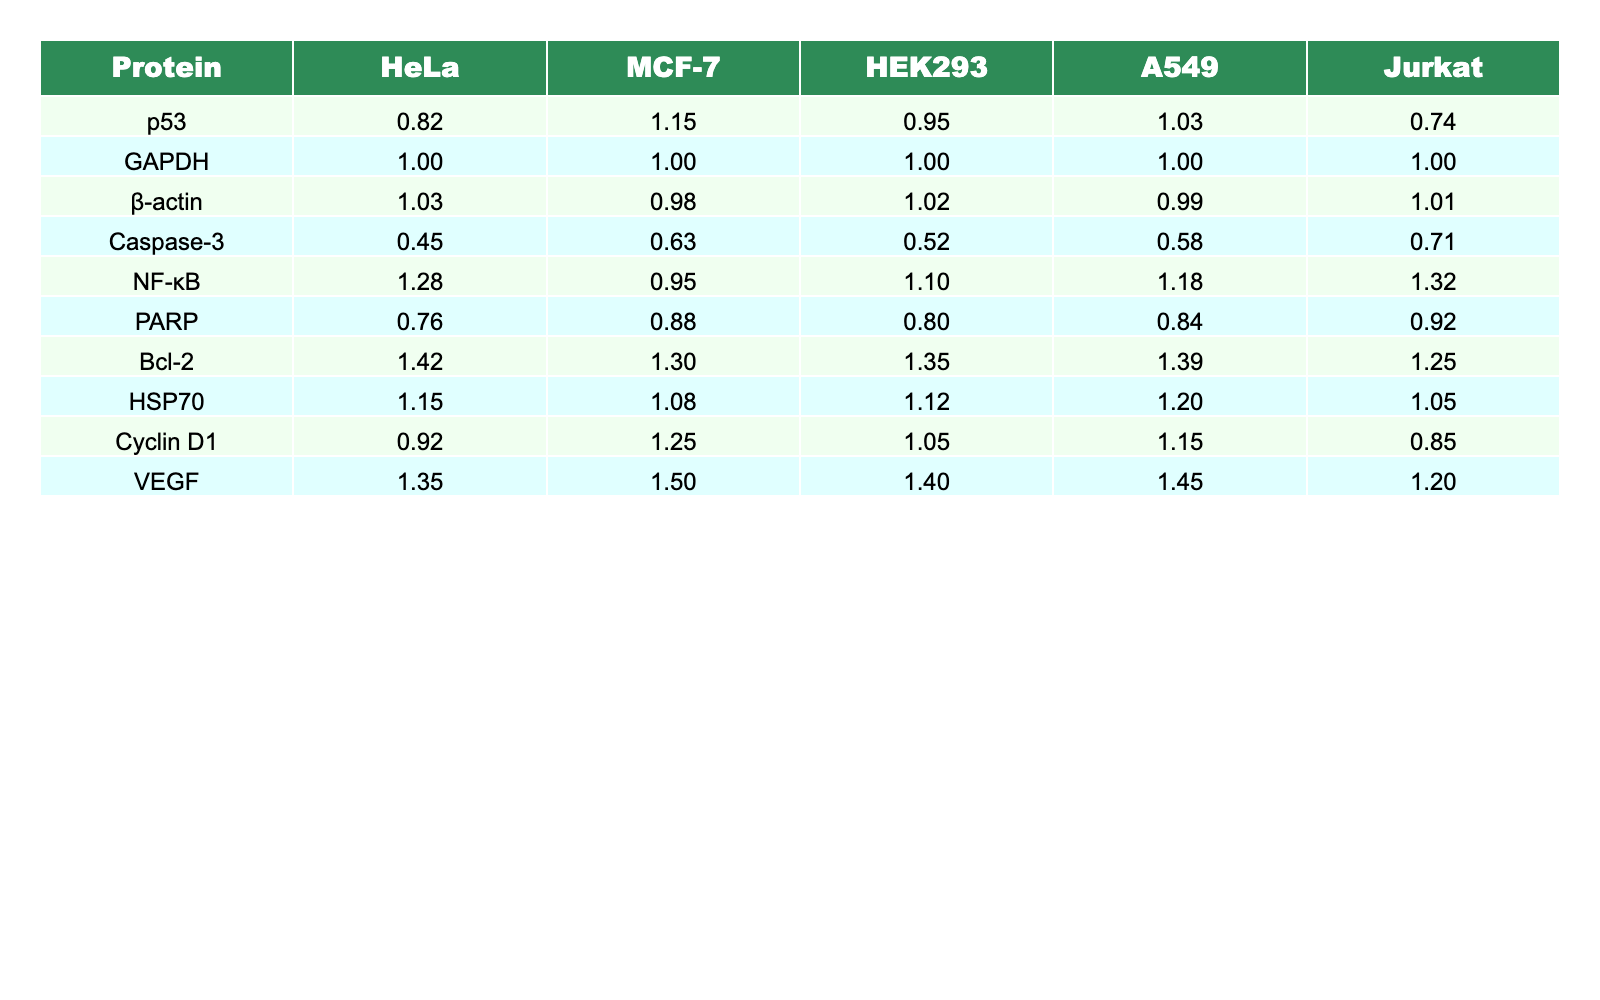What is the value of p53 in MCF-7? The value for p53 in the MCF-7 cell line is clearly indicated in the table under the MCF-7 column, which is 1.15.
Answer: 1.15 Which protein has the highest value in HEK293? By examining the HEK293 column, the protein with the highest quantification value is Bcl-2, which has a value of 1.35.
Answer: Bcl-2 What is the average expression level of Caspase-3 across all cell lines? To find the average expression level of Caspase-3, we need to sum the values (0.45 + 0.63 + 0.52 + 0.58 + 0.71) which equals 2.89, and then divide by the number of cell lines (5). The average is 2.89 / 5 = 0.578.
Answer: 0.578 Is the expression level of VEGF higher in Jurkat than in HeLa? Comparing the values in the table, Jurkat has a value of 1.20 for VEGF, while HeLa has a value of 1.35. Since 1.20 is less than 1.35, the statement is false.
Answer: No What is the difference in expression levels of NF-κB between HeLa and A549? The value for NF-κB in HeLa is 1.28 and in A549 is 1.18. The difference is calculated as 1.28 - 1.18 = 0.10.
Answer: 0.10 Which proteins have expression levels above 1.2 in Jurkat? Looking through the Jurkat column, the proteins with values above 1.2 are NF-κB (1.32), Bcl-2 (1.25), and VEGF (1.20); thus, Bcl-2 and NF-κB are above 1.2 but not VEGF.
Answer: NF-κB, Bcl-2 What is the total expression level of β-actin and GAPDH across all cell lines? The individual values for β-actin are (1.03 + 0.98 + 1.02 + 0.99 + 1.01) = 5.03. The total for GAPDH, which is constant at 1.00 across all lines, is (1.00 * 5 = 5.00). Thus, adding them yields 5.03 + 5.00 = 10.03.
Answer: 10.03 